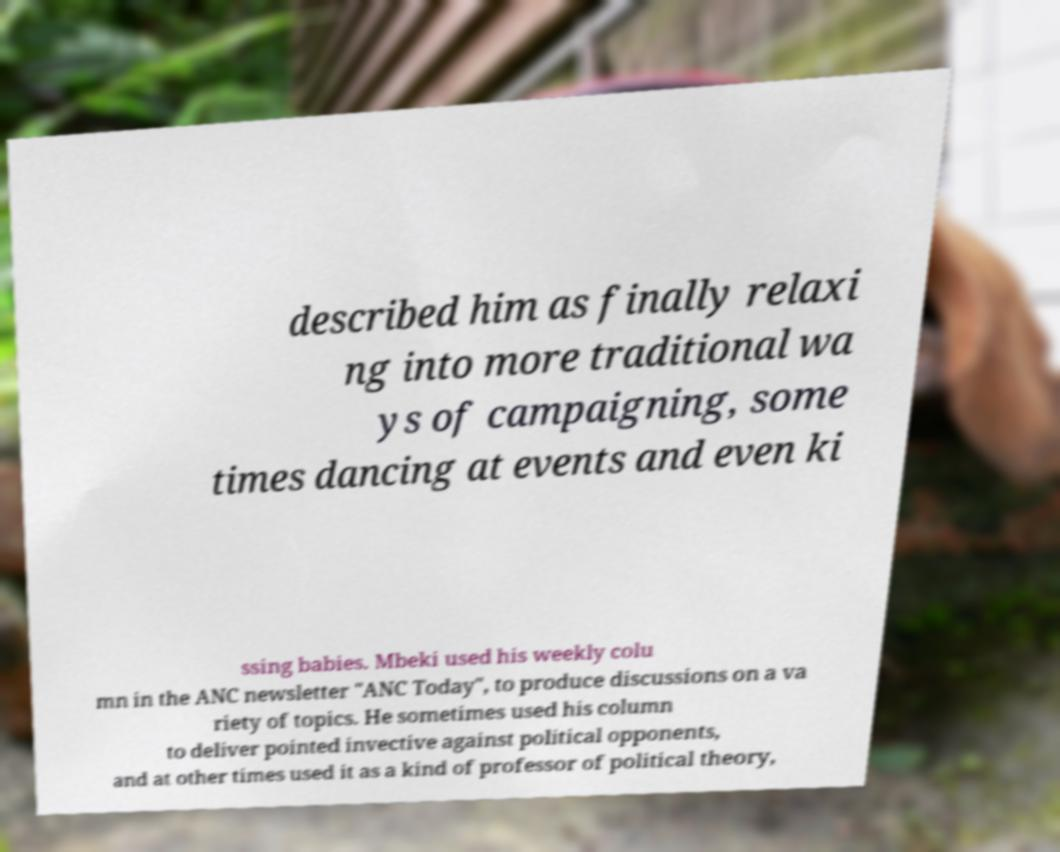What messages or text are displayed in this image? I need them in a readable, typed format. described him as finally relaxi ng into more traditional wa ys of campaigning, some times dancing at events and even ki ssing babies. Mbeki used his weekly colu mn in the ANC newsletter "ANC Today", to produce discussions on a va riety of topics. He sometimes used his column to deliver pointed invective against political opponents, and at other times used it as a kind of professor of political theory, 